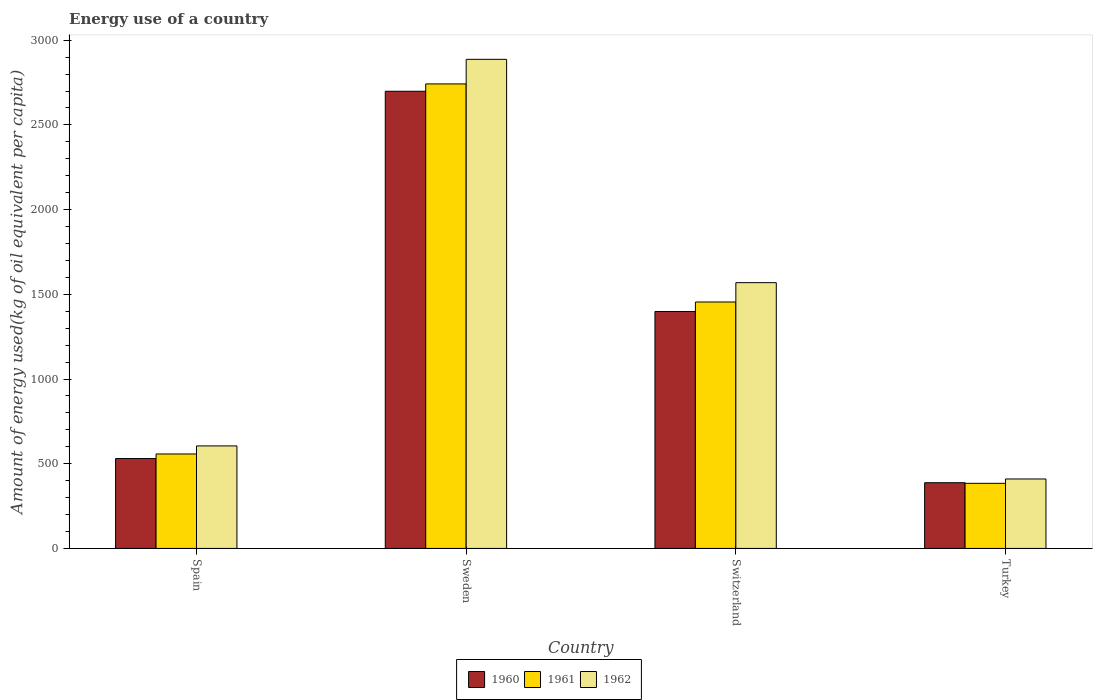Are the number of bars per tick equal to the number of legend labels?
Your answer should be very brief. Yes. Are the number of bars on each tick of the X-axis equal?
Make the answer very short. Yes. How many bars are there on the 4th tick from the left?
Ensure brevity in your answer.  3. What is the label of the 2nd group of bars from the left?
Your answer should be compact. Sweden. In how many cases, is the number of bars for a given country not equal to the number of legend labels?
Offer a terse response. 0. What is the amount of energy used in in 1960 in Switzerland?
Your answer should be very brief. 1398.65. Across all countries, what is the maximum amount of energy used in in 1960?
Give a very brief answer. 2698.79. Across all countries, what is the minimum amount of energy used in in 1962?
Your answer should be compact. 410.02. In which country was the amount of energy used in in 1961 maximum?
Ensure brevity in your answer.  Sweden. In which country was the amount of energy used in in 1960 minimum?
Your answer should be compact. Turkey. What is the total amount of energy used in in 1961 in the graph?
Make the answer very short. 5138.82. What is the difference between the amount of energy used in in 1960 in Spain and that in Turkey?
Your answer should be very brief. 142.69. What is the difference between the amount of energy used in in 1961 in Switzerland and the amount of energy used in in 1962 in Turkey?
Provide a short and direct response. 1044.73. What is the average amount of energy used in in 1960 per country?
Give a very brief answer. 1254.02. What is the difference between the amount of energy used in of/in 1962 and amount of energy used in of/in 1961 in Turkey?
Your response must be concise. 25.68. In how many countries, is the amount of energy used in in 1960 greater than 2100 kg?
Your response must be concise. 1. What is the ratio of the amount of energy used in in 1961 in Sweden to that in Switzerland?
Provide a succinct answer. 1.88. What is the difference between the highest and the second highest amount of energy used in in 1960?
Offer a terse response. 2168.13. What is the difference between the highest and the lowest amount of energy used in in 1961?
Your response must be concise. 2357.78. How many bars are there?
Your answer should be very brief. 12. Are all the bars in the graph horizontal?
Your answer should be compact. No. How many countries are there in the graph?
Provide a short and direct response. 4. Are the values on the major ticks of Y-axis written in scientific E-notation?
Offer a very short reply. No. Where does the legend appear in the graph?
Provide a short and direct response. Bottom center. How many legend labels are there?
Offer a very short reply. 3. What is the title of the graph?
Make the answer very short. Energy use of a country. Does "2006" appear as one of the legend labels in the graph?
Provide a succinct answer. No. What is the label or title of the Y-axis?
Your response must be concise. Amount of energy used(kg of oil equivalent per capita). What is the Amount of energy used(kg of oil equivalent per capita) of 1960 in Spain?
Give a very brief answer. 530.66. What is the Amount of energy used(kg of oil equivalent per capita) in 1961 in Spain?
Give a very brief answer. 557.6. What is the Amount of energy used(kg of oil equivalent per capita) of 1962 in Spain?
Provide a short and direct response. 605.22. What is the Amount of energy used(kg of oil equivalent per capita) of 1960 in Sweden?
Keep it short and to the point. 2698.79. What is the Amount of energy used(kg of oil equivalent per capita) in 1961 in Sweden?
Offer a terse response. 2742.12. What is the Amount of energy used(kg of oil equivalent per capita) of 1962 in Sweden?
Give a very brief answer. 2887.24. What is the Amount of energy used(kg of oil equivalent per capita) in 1960 in Switzerland?
Give a very brief answer. 1398.65. What is the Amount of energy used(kg of oil equivalent per capita) of 1961 in Switzerland?
Your answer should be compact. 1454.76. What is the Amount of energy used(kg of oil equivalent per capita) in 1962 in Switzerland?
Your answer should be very brief. 1568.91. What is the Amount of energy used(kg of oil equivalent per capita) in 1960 in Turkey?
Your answer should be very brief. 387.97. What is the Amount of energy used(kg of oil equivalent per capita) of 1961 in Turkey?
Ensure brevity in your answer.  384.35. What is the Amount of energy used(kg of oil equivalent per capita) in 1962 in Turkey?
Your response must be concise. 410.02. Across all countries, what is the maximum Amount of energy used(kg of oil equivalent per capita) of 1960?
Provide a short and direct response. 2698.79. Across all countries, what is the maximum Amount of energy used(kg of oil equivalent per capita) of 1961?
Keep it short and to the point. 2742.12. Across all countries, what is the maximum Amount of energy used(kg of oil equivalent per capita) of 1962?
Your response must be concise. 2887.24. Across all countries, what is the minimum Amount of energy used(kg of oil equivalent per capita) in 1960?
Give a very brief answer. 387.97. Across all countries, what is the minimum Amount of energy used(kg of oil equivalent per capita) of 1961?
Your response must be concise. 384.35. Across all countries, what is the minimum Amount of energy used(kg of oil equivalent per capita) of 1962?
Give a very brief answer. 410.02. What is the total Amount of energy used(kg of oil equivalent per capita) of 1960 in the graph?
Your answer should be compact. 5016.08. What is the total Amount of energy used(kg of oil equivalent per capita) in 1961 in the graph?
Keep it short and to the point. 5138.82. What is the total Amount of energy used(kg of oil equivalent per capita) of 1962 in the graph?
Offer a terse response. 5471.39. What is the difference between the Amount of energy used(kg of oil equivalent per capita) of 1960 in Spain and that in Sweden?
Ensure brevity in your answer.  -2168.13. What is the difference between the Amount of energy used(kg of oil equivalent per capita) of 1961 in Spain and that in Sweden?
Provide a short and direct response. -2184.52. What is the difference between the Amount of energy used(kg of oil equivalent per capita) in 1962 in Spain and that in Sweden?
Provide a succinct answer. -2282.01. What is the difference between the Amount of energy used(kg of oil equivalent per capita) of 1960 in Spain and that in Switzerland?
Ensure brevity in your answer.  -867.99. What is the difference between the Amount of energy used(kg of oil equivalent per capita) of 1961 in Spain and that in Switzerland?
Provide a short and direct response. -897.16. What is the difference between the Amount of energy used(kg of oil equivalent per capita) of 1962 in Spain and that in Switzerland?
Your response must be concise. -963.69. What is the difference between the Amount of energy used(kg of oil equivalent per capita) of 1960 in Spain and that in Turkey?
Keep it short and to the point. 142.69. What is the difference between the Amount of energy used(kg of oil equivalent per capita) of 1961 in Spain and that in Turkey?
Your answer should be very brief. 173.25. What is the difference between the Amount of energy used(kg of oil equivalent per capita) of 1962 in Spain and that in Turkey?
Offer a very short reply. 195.2. What is the difference between the Amount of energy used(kg of oil equivalent per capita) of 1960 in Sweden and that in Switzerland?
Your answer should be very brief. 1300.14. What is the difference between the Amount of energy used(kg of oil equivalent per capita) in 1961 in Sweden and that in Switzerland?
Offer a terse response. 1287.37. What is the difference between the Amount of energy used(kg of oil equivalent per capita) of 1962 in Sweden and that in Switzerland?
Make the answer very short. 1318.33. What is the difference between the Amount of energy used(kg of oil equivalent per capita) in 1960 in Sweden and that in Turkey?
Your answer should be compact. 2310.82. What is the difference between the Amount of energy used(kg of oil equivalent per capita) in 1961 in Sweden and that in Turkey?
Provide a succinct answer. 2357.78. What is the difference between the Amount of energy used(kg of oil equivalent per capita) in 1962 in Sweden and that in Turkey?
Your answer should be compact. 2477.21. What is the difference between the Amount of energy used(kg of oil equivalent per capita) of 1960 in Switzerland and that in Turkey?
Provide a succinct answer. 1010.68. What is the difference between the Amount of energy used(kg of oil equivalent per capita) of 1961 in Switzerland and that in Turkey?
Give a very brief answer. 1070.41. What is the difference between the Amount of energy used(kg of oil equivalent per capita) of 1962 in Switzerland and that in Turkey?
Provide a short and direct response. 1158.89. What is the difference between the Amount of energy used(kg of oil equivalent per capita) of 1960 in Spain and the Amount of energy used(kg of oil equivalent per capita) of 1961 in Sweden?
Your response must be concise. -2211.46. What is the difference between the Amount of energy used(kg of oil equivalent per capita) of 1960 in Spain and the Amount of energy used(kg of oil equivalent per capita) of 1962 in Sweden?
Ensure brevity in your answer.  -2356.57. What is the difference between the Amount of energy used(kg of oil equivalent per capita) of 1961 in Spain and the Amount of energy used(kg of oil equivalent per capita) of 1962 in Sweden?
Give a very brief answer. -2329.64. What is the difference between the Amount of energy used(kg of oil equivalent per capita) in 1960 in Spain and the Amount of energy used(kg of oil equivalent per capita) in 1961 in Switzerland?
Provide a short and direct response. -924.09. What is the difference between the Amount of energy used(kg of oil equivalent per capita) in 1960 in Spain and the Amount of energy used(kg of oil equivalent per capita) in 1962 in Switzerland?
Provide a succinct answer. -1038.25. What is the difference between the Amount of energy used(kg of oil equivalent per capita) in 1961 in Spain and the Amount of energy used(kg of oil equivalent per capita) in 1962 in Switzerland?
Your answer should be very brief. -1011.31. What is the difference between the Amount of energy used(kg of oil equivalent per capita) in 1960 in Spain and the Amount of energy used(kg of oil equivalent per capita) in 1961 in Turkey?
Keep it short and to the point. 146.32. What is the difference between the Amount of energy used(kg of oil equivalent per capita) of 1960 in Spain and the Amount of energy used(kg of oil equivalent per capita) of 1962 in Turkey?
Keep it short and to the point. 120.64. What is the difference between the Amount of energy used(kg of oil equivalent per capita) of 1961 in Spain and the Amount of energy used(kg of oil equivalent per capita) of 1962 in Turkey?
Offer a very short reply. 147.58. What is the difference between the Amount of energy used(kg of oil equivalent per capita) in 1960 in Sweden and the Amount of energy used(kg of oil equivalent per capita) in 1961 in Switzerland?
Provide a short and direct response. 1244.04. What is the difference between the Amount of energy used(kg of oil equivalent per capita) of 1960 in Sweden and the Amount of energy used(kg of oil equivalent per capita) of 1962 in Switzerland?
Offer a very short reply. 1129.88. What is the difference between the Amount of energy used(kg of oil equivalent per capita) in 1961 in Sweden and the Amount of energy used(kg of oil equivalent per capita) in 1962 in Switzerland?
Provide a short and direct response. 1173.21. What is the difference between the Amount of energy used(kg of oil equivalent per capita) of 1960 in Sweden and the Amount of energy used(kg of oil equivalent per capita) of 1961 in Turkey?
Your answer should be very brief. 2314.45. What is the difference between the Amount of energy used(kg of oil equivalent per capita) in 1960 in Sweden and the Amount of energy used(kg of oil equivalent per capita) in 1962 in Turkey?
Your answer should be very brief. 2288.77. What is the difference between the Amount of energy used(kg of oil equivalent per capita) in 1961 in Sweden and the Amount of energy used(kg of oil equivalent per capita) in 1962 in Turkey?
Your answer should be very brief. 2332.1. What is the difference between the Amount of energy used(kg of oil equivalent per capita) of 1960 in Switzerland and the Amount of energy used(kg of oil equivalent per capita) of 1961 in Turkey?
Offer a terse response. 1014.31. What is the difference between the Amount of energy used(kg of oil equivalent per capita) of 1960 in Switzerland and the Amount of energy used(kg of oil equivalent per capita) of 1962 in Turkey?
Your answer should be very brief. 988.63. What is the difference between the Amount of energy used(kg of oil equivalent per capita) in 1961 in Switzerland and the Amount of energy used(kg of oil equivalent per capita) in 1962 in Turkey?
Ensure brevity in your answer.  1044.73. What is the average Amount of energy used(kg of oil equivalent per capita) in 1960 per country?
Your response must be concise. 1254.02. What is the average Amount of energy used(kg of oil equivalent per capita) in 1961 per country?
Your answer should be very brief. 1284.71. What is the average Amount of energy used(kg of oil equivalent per capita) of 1962 per country?
Your answer should be very brief. 1367.85. What is the difference between the Amount of energy used(kg of oil equivalent per capita) in 1960 and Amount of energy used(kg of oil equivalent per capita) in 1961 in Spain?
Your answer should be very brief. -26.93. What is the difference between the Amount of energy used(kg of oil equivalent per capita) in 1960 and Amount of energy used(kg of oil equivalent per capita) in 1962 in Spain?
Ensure brevity in your answer.  -74.56. What is the difference between the Amount of energy used(kg of oil equivalent per capita) of 1961 and Amount of energy used(kg of oil equivalent per capita) of 1962 in Spain?
Make the answer very short. -47.62. What is the difference between the Amount of energy used(kg of oil equivalent per capita) in 1960 and Amount of energy used(kg of oil equivalent per capita) in 1961 in Sweden?
Provide a succinct answer. -43.33. What is the difference between the Amount of energy used(kg of oil equivalent per capita) of 1960 and Amount of energy used(kg of oil equivalent per capita) of 1962 in Sweden?
Provide a succinct answer. -188.44. What is the difference between the Amount of energy used(kg of oil equivalent per capita) of 1961 and Amount of energy used(kg of oil equivalent per capita) of 1962 in Sweden?
Make the answer very short. -145.11. What is the difference between the Amount of energy used(kg of oil equivalent per capita) of 1960 and Amount of energy used(kg of oil equivalent per capita) of 1961 in Switzerland?
Your answer should be very brief. -56.1. What is the difference between the Amount of energy used(kg of oil equivalent per capita) in 1960 and Amount of energy used(kg of oil equivalent per capita) in 1962 in Switzerland?
Ensure brevity in your answer.  -170.26. What is the difference between the Amount of energy used(kg of oil equivalent per capita) of 1961 and Amount of energy used(kg of oil equivalent per capita) of 1962 in Switzerland?
Give a very brief answer. -114.16. What is the difference between the Amount of energy used(kg of oil equivalent per capita) of 1960 and Amount of energy used(kg of oil equivalent per capita) of 1961 in Turkey?
Your answer should be very brief. 3.62. What is the difference between the Amount of energy used(kg of oil equivalent per capita) of 1960 and Amount of energy used(kg of oil equivalent per capita) of 1962 in Turkey?
Provide a succinct answer. -22.05. What is the difference between the Amount of energy used(kg of oil equivalent per capita) in 1961 and Amount of energy used(kg of oil equivalent per capita) in 1962 in Turkey?
Ensure brevity in your answer.  -25.68. What is the ratio of the Amount of energy used(kg of oil equivalent per capita) of 1960 in Spain to that in Sweden?
Keep it short and to the point. 0.2. What is the ratio of the Amount of energy used(kg of oil equivalent per capita) in 1961 in Spain to that in Sweden?
Your answer should be compact. 0.2. What is the ratio of the Amount of energy used(kg of oil equivalent per capita) in 1962 in Spain to that in Sweden?
Keep it short and to the point. 0.21. What is the ratio of the Amount of energy used(kg of oil equivalent per capita) of 1960 in Spain to that in Switzerland?
Keep it short and to the point. 0.38. What is the ratio of the Amount of energy used(kg of oil equivalent per capita) of 1961 in Spain to that in Switzerland?
Make the answer very short. 0.38. What is the ratio of the Amount of energy used(kg of oil equivalent per capita) in 1962 in Spain to that in Switzerland?
Give a very brief answer. 0.39. What is the ratio of the Amount of energy used(kg of oil equivalent per capita) in 1960 in Spain to that in Turkey?
Ensure brevity in your answer.  1.37. What is the ratio of the Amount of energy used(kg of oil equivalent per capita) of 1961 in Spain to that in Turkey?
Offer a very short reply. 1.45. What is the ratio of the Amount of energy used(kg of oil equivalent per capita) in 1962 in Spain to that in Turkey?
Give a very brief answer. 1.48. What is the ratio of the Amount of energy used(kg of oil equivalent per capita) in 1960 in Sweden to that in Switzerland?
Your answer should be very brief. 1.93. What is the ratio of the Amount of energy used(kg of oil equivalent per capita) in 1961 in Sweden to that in Switzerland?
Your response must be concise. 1.88. What is the ratio of the Amount of energy used(kg of oil equivalent per capita) in 1962 in Sweden to that in Switzerland?
Offer a terse response. 1.84. What is the ratio of the Amount of energy used(kg of oil equivalent per capita) of 1960 in Sweden to that in Turkey?
Offer a terse response. 6.96. What is the ratio of the Amount of energy used(kg of oil equivalent per capita) in 1961 in Sweden to that in Turkey?
Your response must be concise. 7.13. What is the ratio of the Amount of energy used(kg of oil equivalent per capita) of 1962 in Sweden to that in Turkey?
Keep it short and to the point. 7.04. What is the ratio of the Amount of energy used(kg of oil equivalent per capita) in 1960 in Switzerland to that in Turkey?
Ensure brevity in your answer.  3.61. What is the ratio of the Amount of energy used(kg of oil equivalent per capita) in 1961 in Switzerland to that in Turkey?
Make the answer very short. 3.79. What is the ratio of the Amount of energy used(kg of oil equivalent per capita) of 1962 in Switzerland to that in Turkey?
Make the answer very short. 3.83. What is the difference between the highest and the second highest Amount of energy used(kg of oil equivalent per capita) in 1960?
Keep it short and to the point. 1300.14. What is the difference between the highest and the second highest Amount of energy used(kg of oil equivalent per capita) in 1961?
Offer a very short reply. 1287.37. What is the difference between the highest and the second highest Amount of energy used(kg of oil equivalent per capita) in 1962?
Make the answer very short. 1318.33. What is the difference between the highest and the lowest Amount of energy used(kg of oil equivalent per capita) in 1960?
Your answer should be very brief. 2310.82. What is the difference between the highest and the lowest Amount of energy used(kg of oil equivalent per capita) in 1961?
Make the answer very short. 2357.78. What is the difference between the highest and the lowest Amount of energy used(kg of oil equivalent per capita) of 1962?
Provide a succinct answer. 2477.21. 